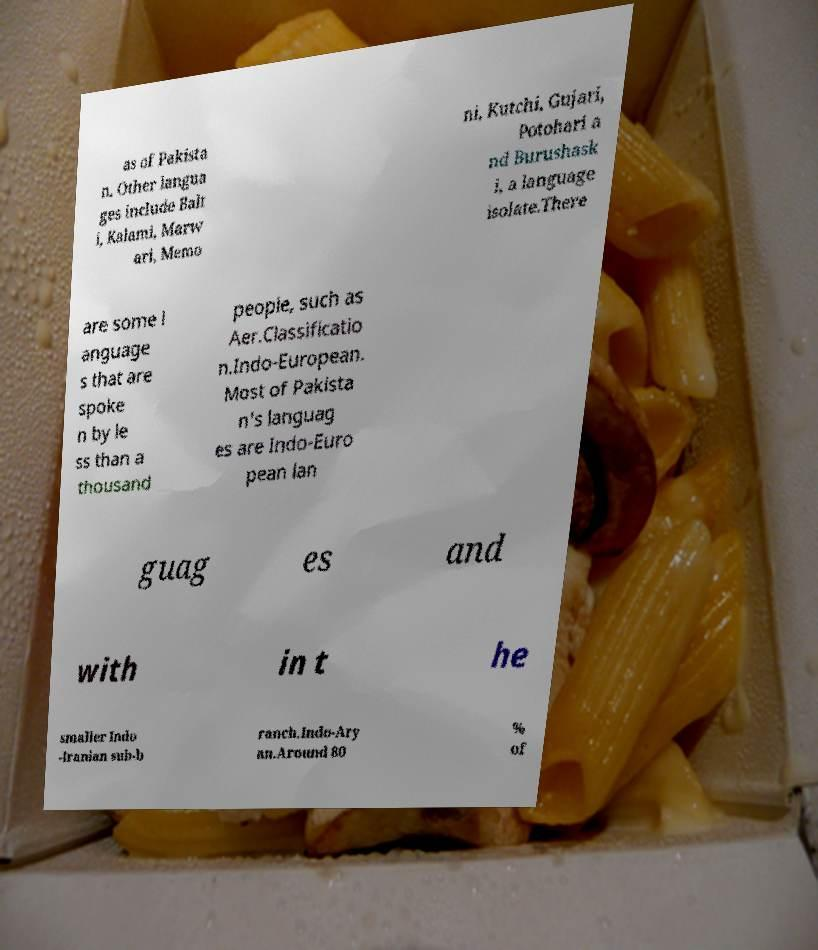There's text embedded in this image that I need extracted. Can you transcribe it verbatim? as of Pakista n. Other langua ges include Balt i, Kalami, Marw ari, Memo ni, Kutchi, Gujari, Potohari a nd Burushask i, a language isolate.There are some l anguage s that are spoke n by le ss than a thousand people, such as Aer.Classificatio n.Indo-European. Most of Pakista n's languag es are Indo-Euro pean lan guag es and with in t he smaller Indo -Iranian sub-b ranch.Indo-Ary an.Around 80 % of 